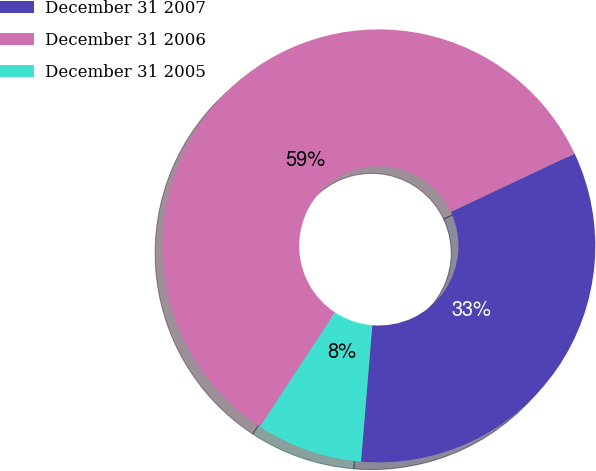Convert chart to OTSL. <chart><loc_0><loc_0><loc_500><loc_500><pie_chart><fcel>December 31 2007<fcel>December 31 2006<fcel>December 31 2005<nl><fcel>33.33%<fcel>58.73%<fcel>7.94%<nl></chart> 